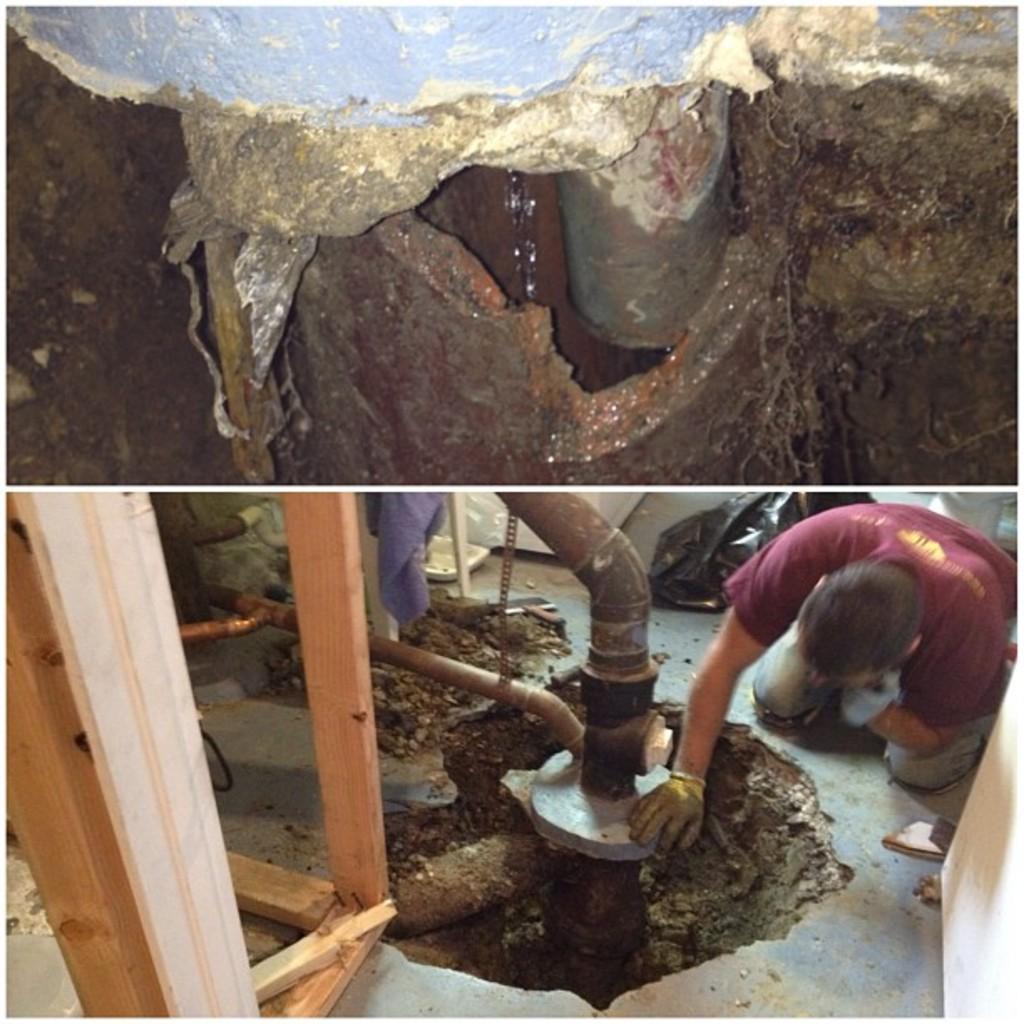Describe this image in one or two sentences. In the image I can see the collage pictures in which there is the picture of a pipe line and in the other picture there is a person who is doing something with the pipeline. 